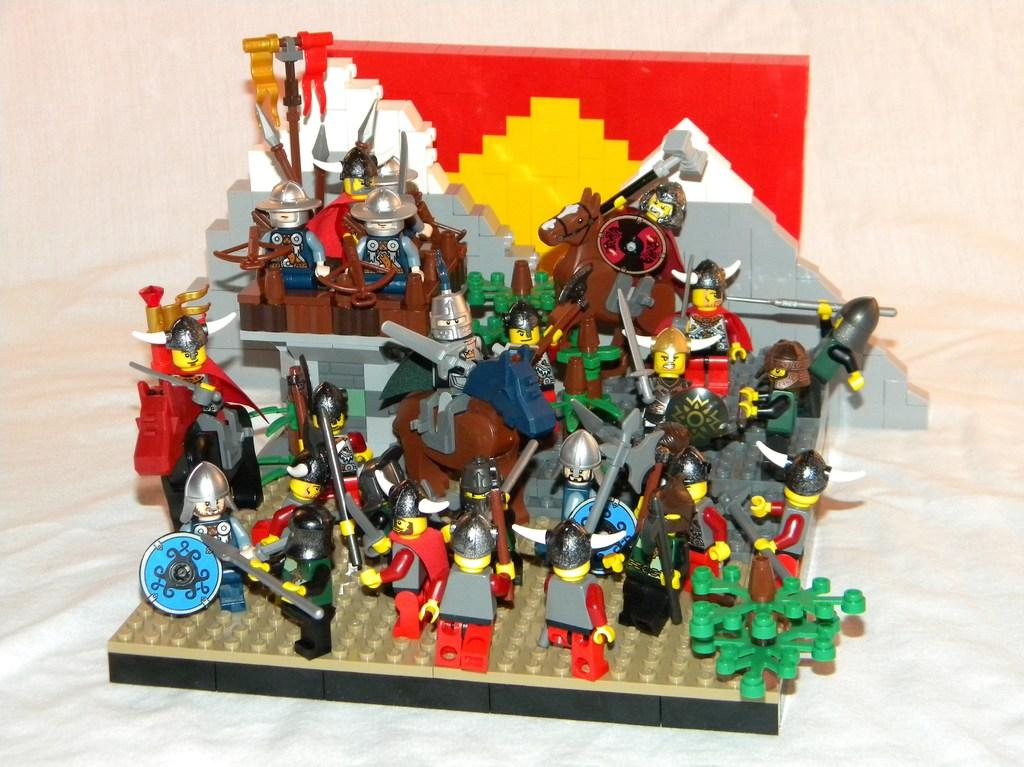What is the main subject of the image? The main subject of the image is toys. Where are the toys located in the image? The toys are in the center of the image. What type of cloth is used to make the steel toys in the image? There is no mention of cloth or steel in the image; it only features toys. 